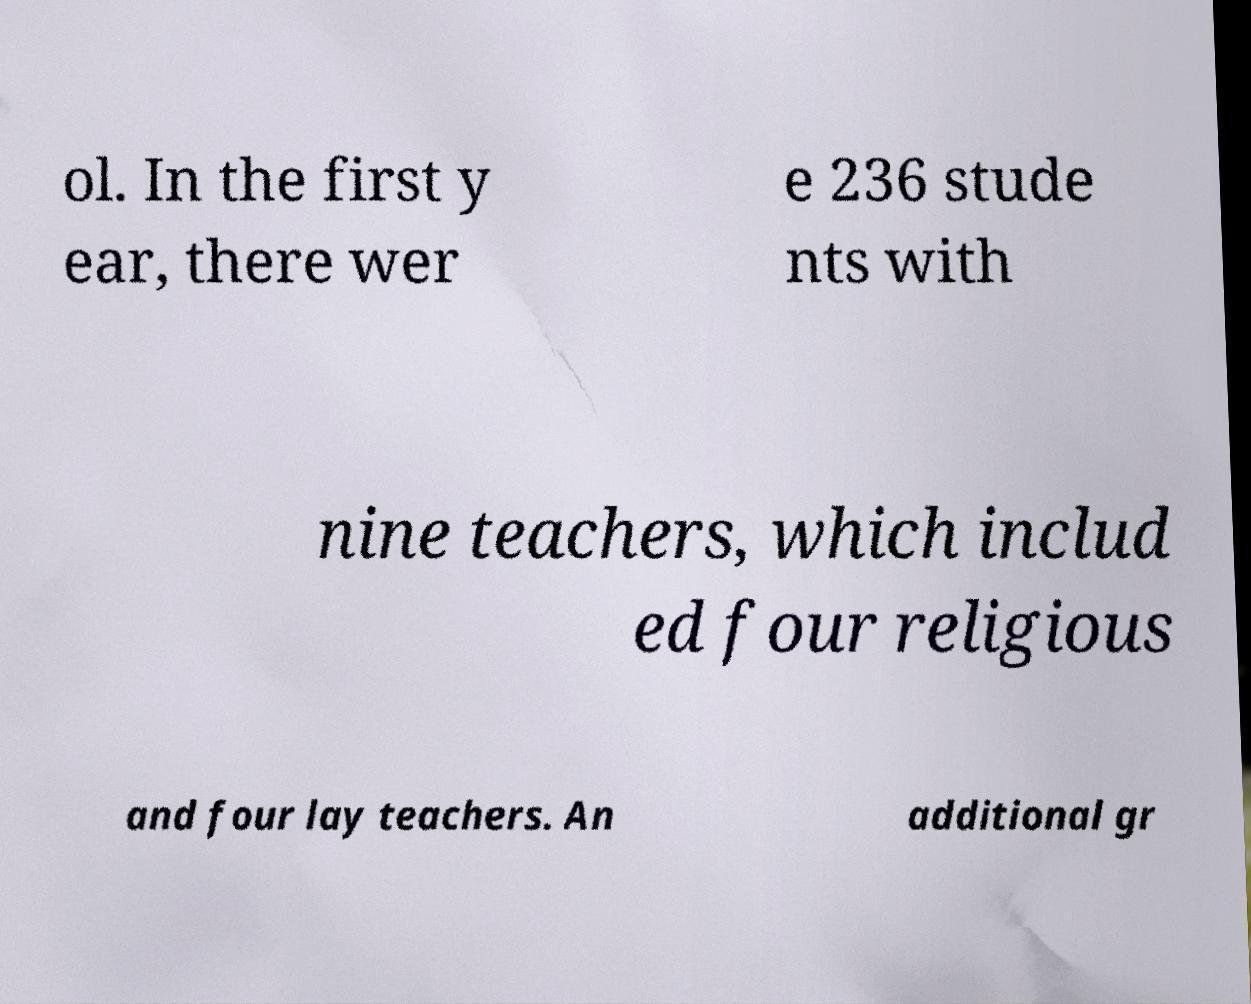Please read and relay the text visible in this image. What does it say? ol. In the first y ear, there wer e 236 stude nts with nine teachers, which includ ed four religious and four lay teachers. An additional gr 